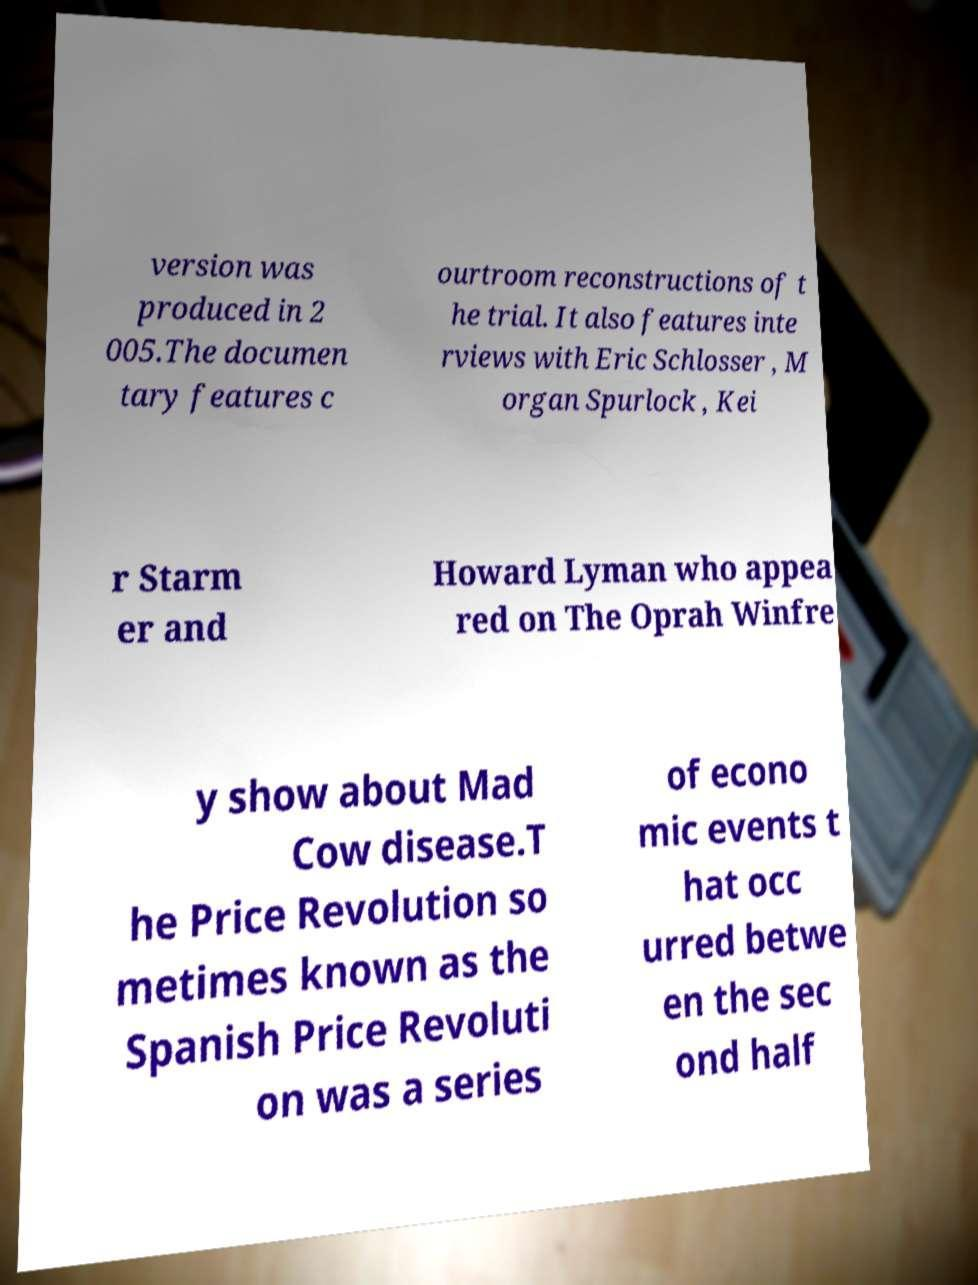Can you read and provide the text displayed in the image?This photo seems to have some interesting text. Can you extract and type it out for me? version was produced in 2 005.The documen tary features c ourtroom reconstructions of t he trial. It also features inte rviews with Eric Schlosser , M organ Spurlock , Kei r Starm er and Howard Lyman who appea red on The Oprah Winfre y show about Mad Cow disease.T he Price Revolution so metimes known as the Spanish Price Revoluti on was a series of econo mic events t hat occ urred betwe en the sec ond half 